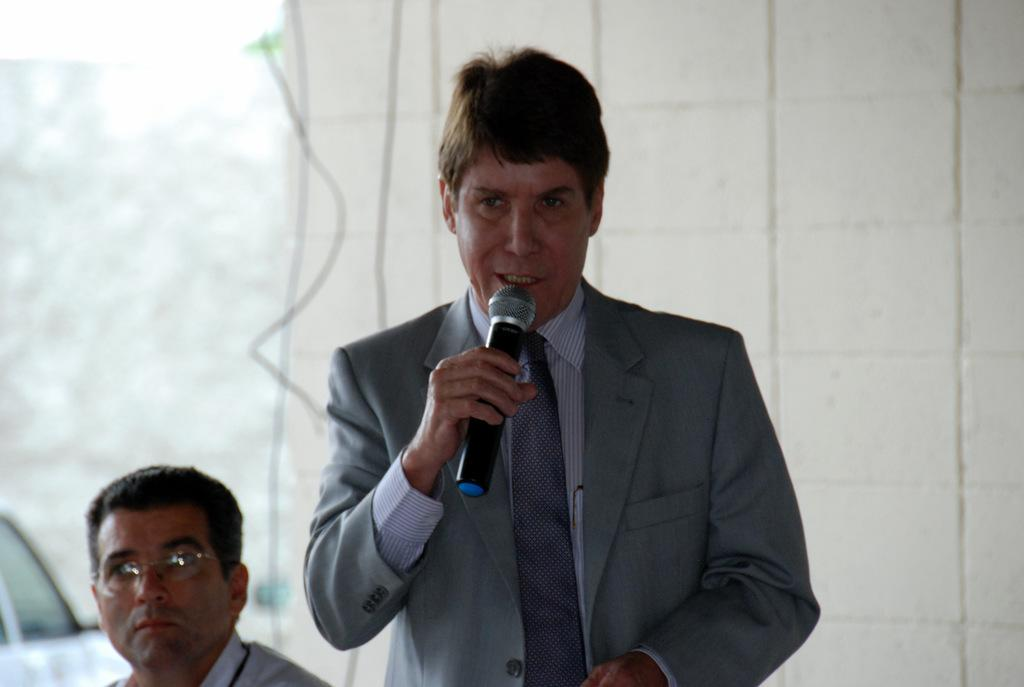What is the man in the image doing? The man is standing in the image and holding a microphone in his hand. What might the man be doing with the microphone? The man is likely talking, as he is holding a microphone. Can you describe the background of the image? There is another man in the background of the image, and there is a white color wall in the background. What type of sofa can be seen in the image? There is no sofa present in the image. How many points does the hill in the image have? There is no hill present in the image. 